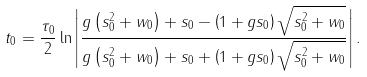Convert formula to latex. <formula><loc_0><loc_0><loc_500><loc_500>t _ { 0 } = \frac { \tau _ { 0 } } 2 \ln \left | \frac { g \left ( s _ { 0 } ^ { 2 } + w _ { 0 } \right ) + s _ { 0 } - \left ( 1 + g s _ { 0 } \right ) \sqrt { s _ { 0 } ^ { 2 } + w _ { 0 } } } { g \left ( s _ { 0 } ^ { 2 } + w _ { 0 } \right ) + s _ { 0 } + \left ( 1 + g s _ { 0 } \right ) \sqrt { s _ { 0 } ^ { 2 } + w _ { 0 } } } \right | .</formula> 